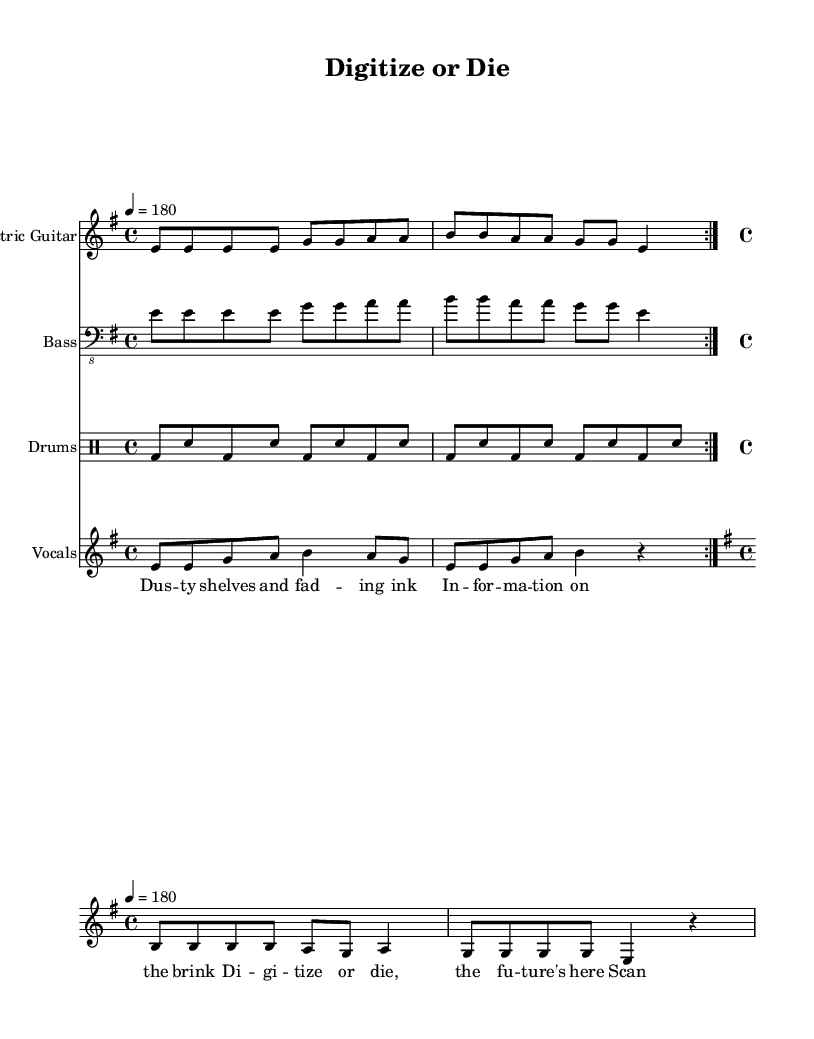What is the key signature of this music? The key signature indicated on the staff shows that there are no sharps or flats, identifying the piece as E minor.
Answer: E minor What is the time signature of this music? The time signature is displayed at the beginning of the staff, indicating that each measure consists of four beats, making it a 4/4 time signature.
Answer: 4/4 What is the tempo marking for this music? The tempo marking is specified at the beginning with a quarter note equaling 180 beats per minute, indicating a fast pace.
Answer: 180 How many times is the verse repeated? The section labeled "verse" includes a repeat indication (volta), which states that the verse is played two times in total.
Answer: 2 What is the primary theme of the lyrics in the chorus? The chorus lyrics focus on the urgency and importance of digitization in preserving information, conveying a message about adapting to technological change.
Answer: Digitize or die What instruments are featured in this sheet music? The sheet music includes parts for Electric Guitar, Bass, Drums, and Vocals, making a standard punk band setup.
Answer: Electric Guitar, Bass, Drums, Vocals What musical style does this piece represent? The characteristics of fast tempo, aggressive instrumentation, and themes of digital revolution relate to the punk genre, known for its raw energy and social commentary.
Answer: Punk 